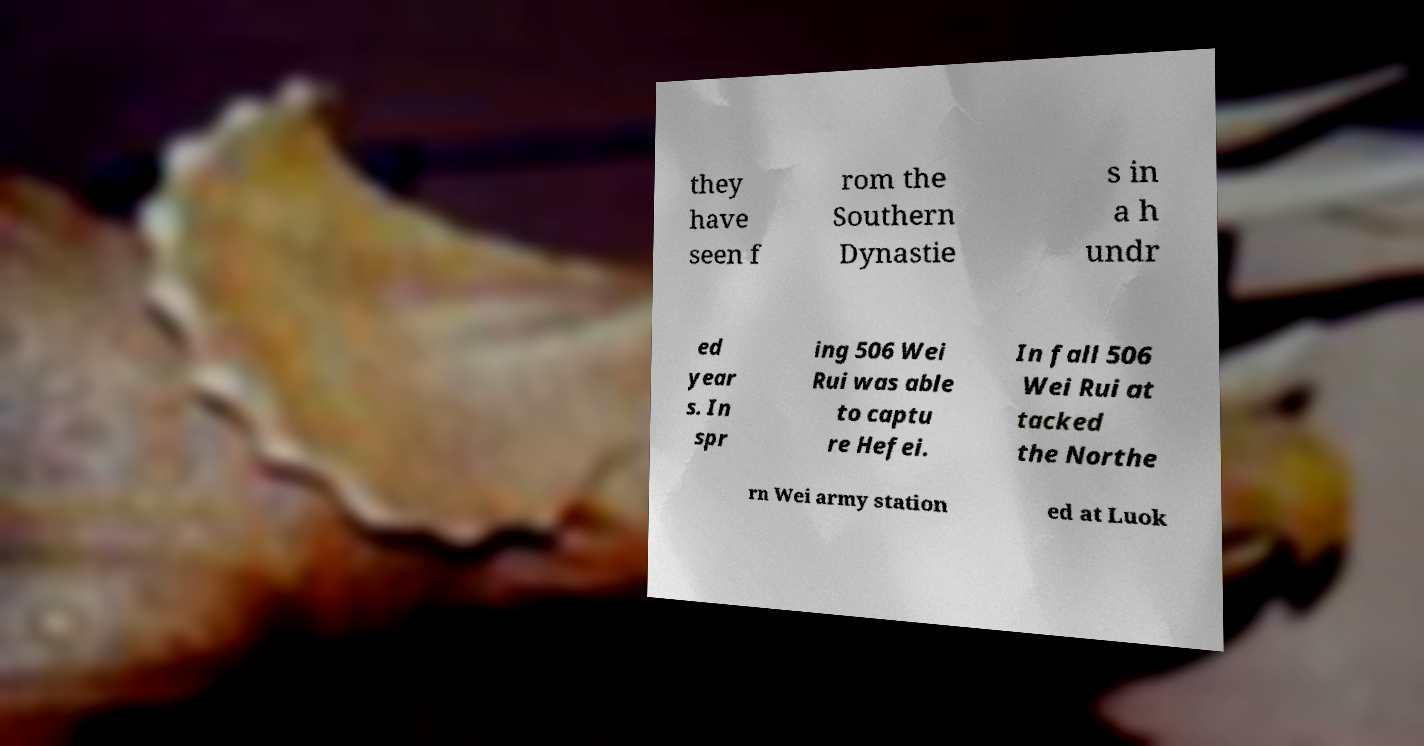Please read and relay the text visible in this image. What does it say? they have seen f rom the Southern Dynastie s in a h undr ed year s. In spr ing 506 Wei Rui was able to captu re Hefei. In fall 506 Wei Rui at tacked the Northe rn Wei army station ed at Luok 